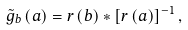Convert formula to latex. <formula><loc_0><loc_0><loc_500><loc_500>\tilde { g } _ { b } \left ( a \right ) = r \left ( b \right ) * \left [ r \left ( a \right ) \right ] ^ { - 1 } ,</formula> 